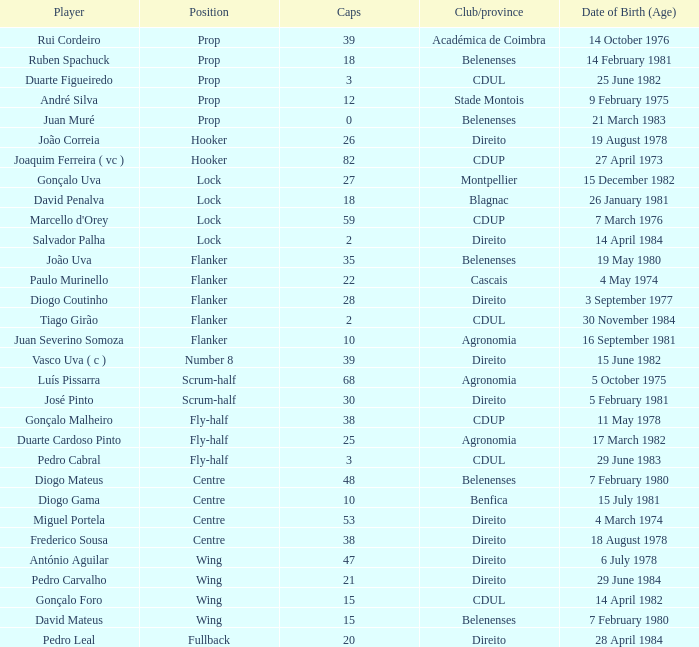Which Club/province has a Player of david penalva? Blagnac. 